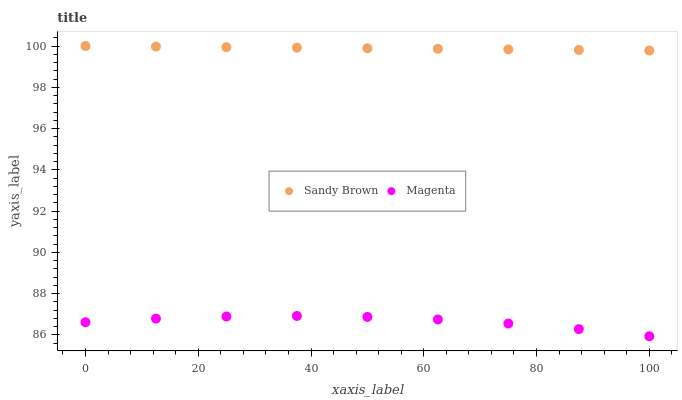Does Magenta have the minimum area under the curve?
Answer yes or no. Yes. Does Sandy Brown have the maximum area under the curve?
Answer yes or no. Yes. Does Sandy Brown have the minimum area under the curve?
Answer yes or no. No. Is Sandy Brown the smoothest?
Answer yes or no. Yes. Is Magenta the roughest?
Answer yes or no. Yes. Is Sandy Brown the roughest?
Answer yes or no. No. Does Magenta have the lowest value?
Answer yes or no. Yes. Does Sandy Brown have the lowest value?
Answer yes or no. No. Does Sandy Brown have the highest value?
Answer yes or no. Yes. Is Magenta less than Sandy Brown?
Answer yes or no. Yes. Is Sandy Brown greater than Magenta?
Answer yes or no. Yes. Does Magenta intersect Sandy Brown?
Answer yes or no. No. 